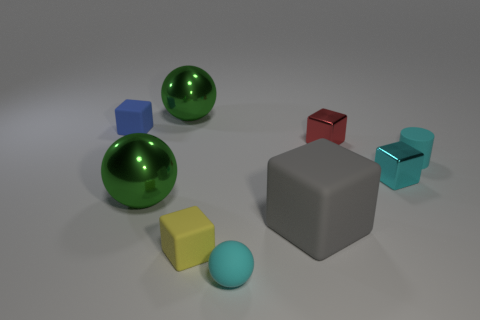Can you tell me the colors of the objects, and how many objects share the same color? Certainly! There are two green, reflective spheres. Then, there is a single large gray cube with a matte finish. Additionally, there are two smaller blue objects: one is a cube and the other is a rectangular prism. Lastly, there's a small yellow cube and a small light blue sphere. Each object's color is unique, except for the two green spheres which share the same color. 